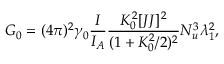Convert formula to latex. <formula><loc_0><loc_0><loc_500><loc_500>G _ { 0 } = ( 4 \pi ) ^ { 2 } \gamma _ { 0 } \frac { I } { I _ { A } } \frac { K _ { 0 } ^ { 2 } [ J J ] ^ { 2 } } { ( 1 + K _ { 0 } ^ { 2 } / 2 ) ^ { 2 } } N _ { u } ^ { 3 } \lambda _ { 1 } ^ { 2 } ,</formula> 